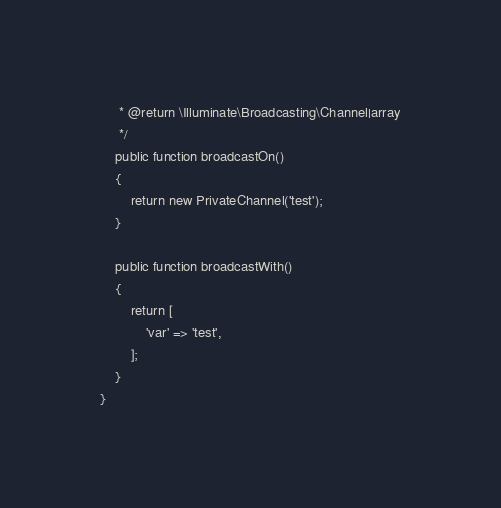Convert code to text. <code><loc_0><loc_0><loc_500><loc_500><_PHP_>     * @return \Illuminate\Broadcasting\Channel|array
     */
    public function broadcastOn()
    {
        return new PrivateChannel('test');
    }

    public function broadcastWith()
    {
        return [
            'var' => 'test',
        ];
    }
}
</code> 